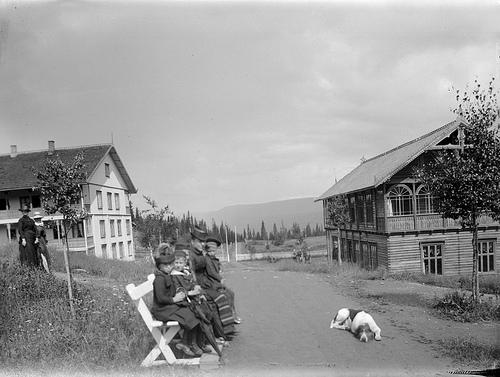What are the people sitting on?
Answer briefly. Bench. What animal lies in the road?
Write a very short answer. Dog. Does this photo look vintage?
Write a very short answer. Yes. 